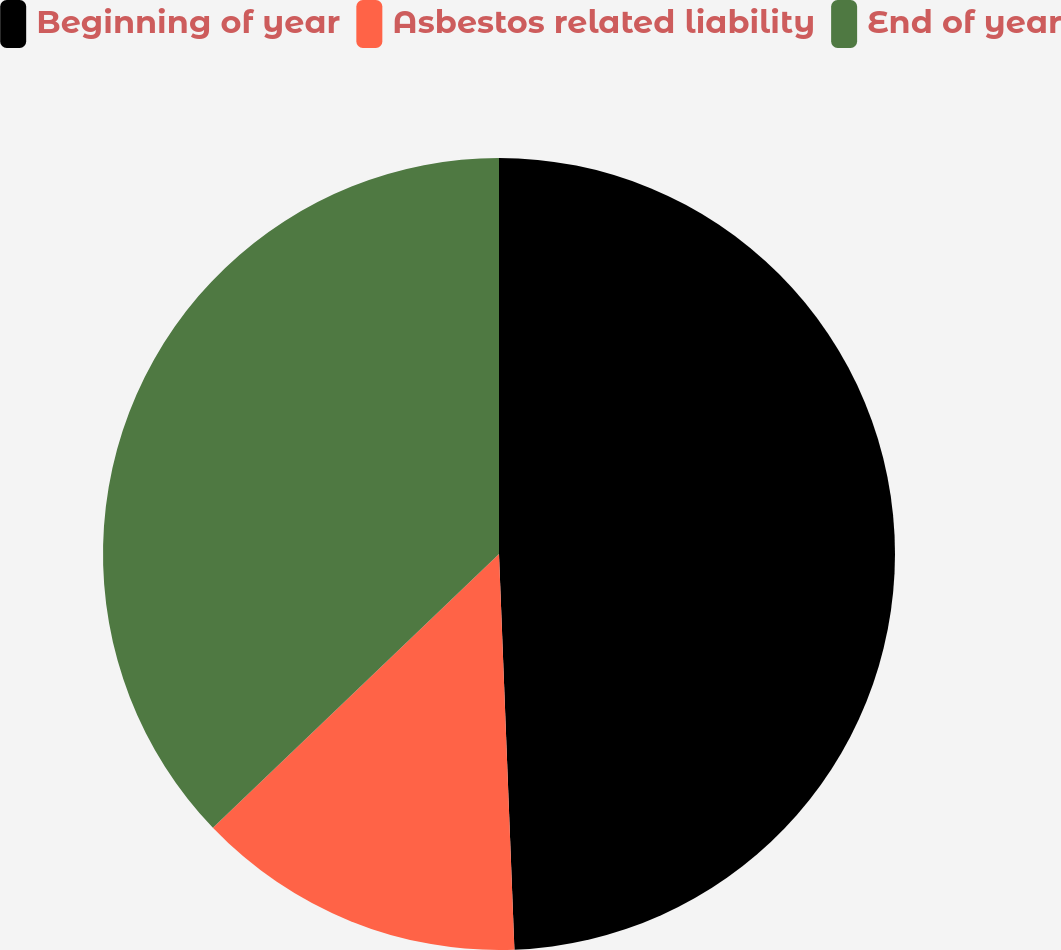<chart> <loc_0><loc_0><loc_500><loc_500><pie_chart><fcel>Beginning of year<fcel>Asbestos related liability<fcel>End of year<nl><fcel>49.38%<fcel>13.47%<fcel>37.15%<nl></chart> 